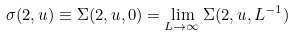<formula> <loc_0><loc_0><loc_500><loc_500>\sigma ( 2 , u ) \equiv \Sigma ( 2 , u , 0 ) = \lim _ { L \rightarrow \infty } \Sigma ( 2 , u , L ^ { - 1 } )</formula> 